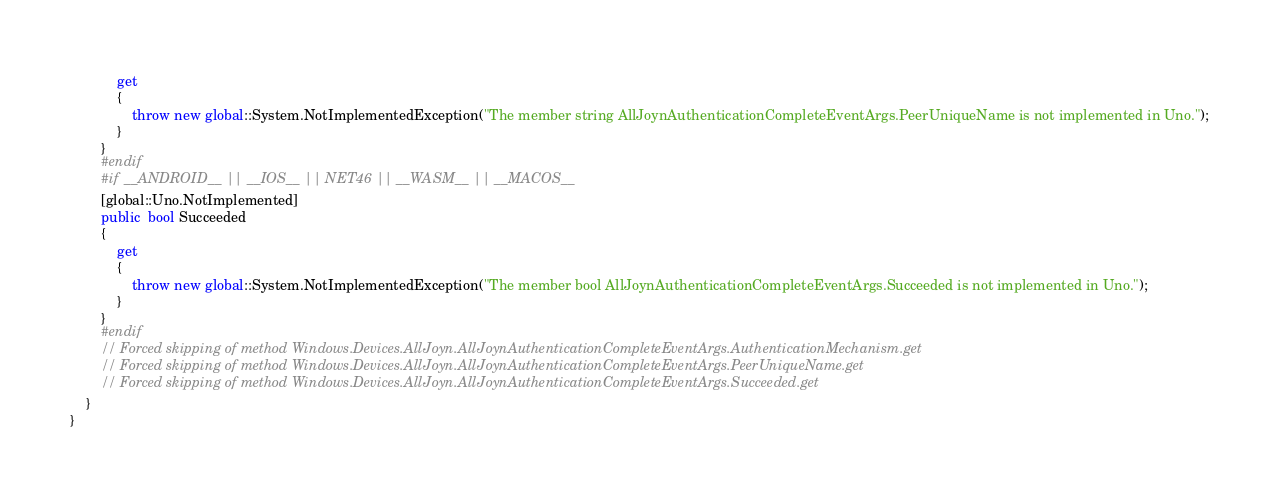<code> <loc_0><loc_0><loc_500><loc_500><_C#_>			get
			{
				throw new global::System.NotImplementedException("The member string AllJoynAuthenticationCompleteEventArgs.PeerUniqueName is not implemented in Uno.");
			}
		}
		#endif
		#if __ANDROID__ || __IOS__ || NET46 || __WASM__ || __MACOS__
		[global::Uno.NotImplemented]
		public  bool Succeeded
		{
			get
			{
				throw new global::System.NotImplementedException("The member bool AllJoynAuthenticationCompleteEventArgs.Succeeded is not implemented in Uno.");
			}
		}
		#endif
		// Forced skipping of method Windows.Devices.AllJoyn.AllJoynAuthenticationCompleteEventArgs.AuthenticationMechanism.get
		// Forced skipping of method Windows.Devices.AllJoyn.AllJoynAuthenticationCompleteEventArgs.PeerUniqueName.get
		// Forced skipping of method Windows.Devices.AllJoyn.AllJoynAuthenticationCompleteEventArgs.Succeeded.get
	}
}
</code> 